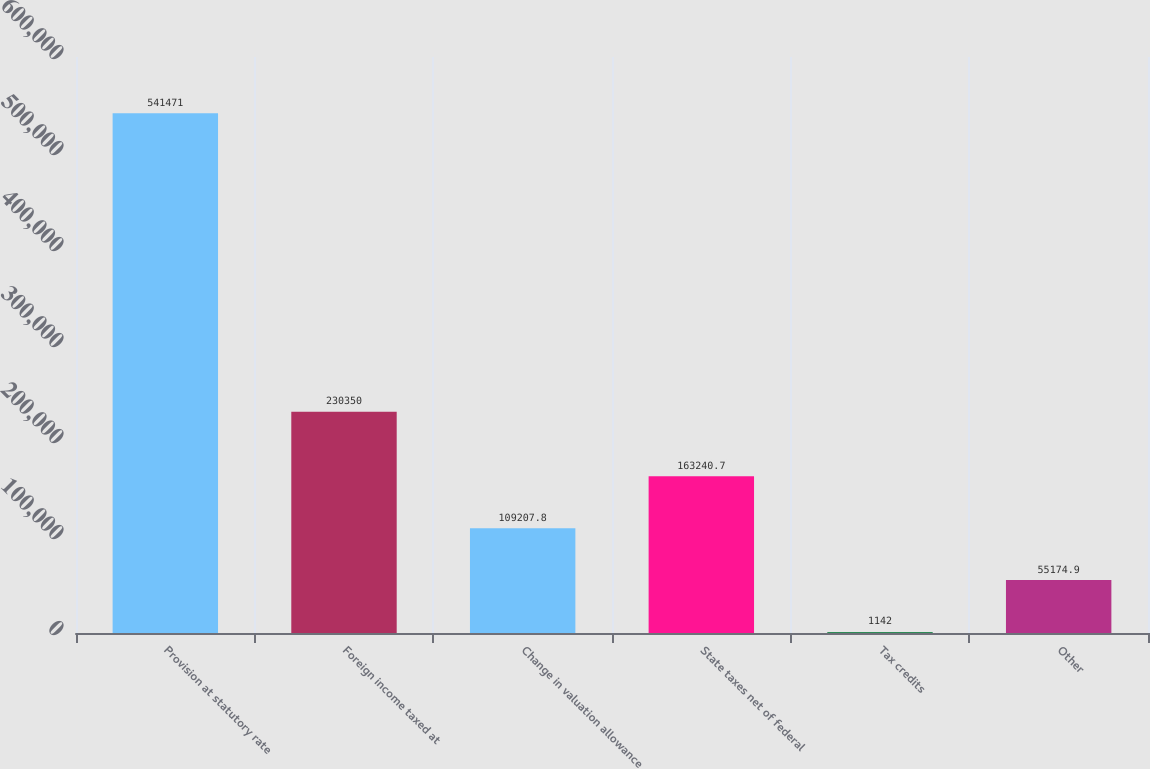Convert chart. <chart><loc_0><loc_0><loc_500><loc_500><bar_chart><fcel>Provision at statutory rate<fcel>Foreign income taxed at<fcel>Change in valuation allowance<fcel>State taxes net of federal<fcel>Tax credits<fcel>Other<nl><fcel>541471<fcel>230350<fcel>109208<fcel>163241<fcel>1142<fcel>55174.9<nl></chart> 